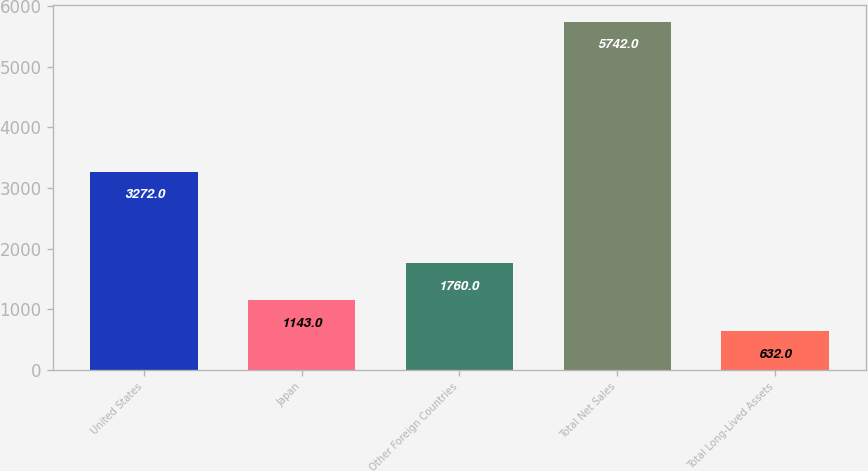<chart> <loc_0><loc_0><loc_500><loc_500><bar_chart><fcel>United States<fcel>Japan<fcel>Other Foreign Countries<fcel>Total Net Sales<fcel>Total Long-Lived Assets<nl><fcel>3272<fcel>1143<fcel>1760<fcel>5742<fcel>632<nl></chart> 